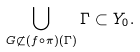<formula> <loc_0><loc_0><loc_500><loc_500>\bigcup _ { G \not \subset ( f \circ \pi ) ( \Gamma ) } \Gamma \subset Y _ { 0 } .</formula> 